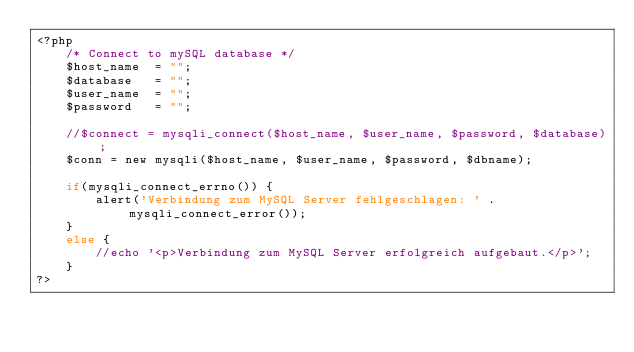<code> <loc_0><loc_0><loc_500><loc_500><_PHP_><?php
	/* Connect to mySQL database */
    $host_name  = "";
    $database   = "";
    $user_name  = "";
    $password   = "";

    //$connect = mysqli_connect($host_name, $user_name, $password, $database);
	$conn = new mysqli($host_name, $user_name, $password, $dbname);
    
    if(mysqli_connect_errno()) {
		alert('Verbindung zum MySQL Server fehlgeschlagen: ' . mysqli_connect_error());
    }
    else {
		//echo '<p>Verbindung zum MySQL Server erfolgreich aufgebaut.</p>';
    }
?></code> 